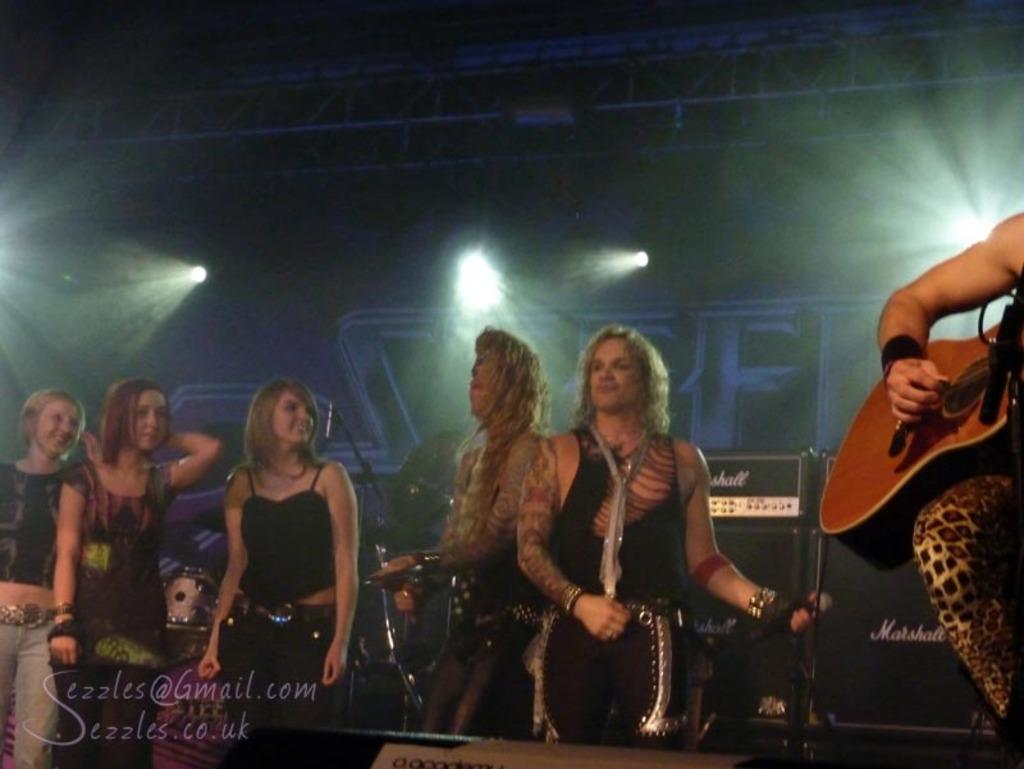Who or what is present in the image? A: There are people in the image. What are the people doing in the image? The people are standing in the image. What objects are the people holding in their hands? The people are holding guitars in their hands. What type of swing can be seen in the image? There is no swing present in the image. Is the queen in the image? There is no mention of a queen or any royal figure in the image. 